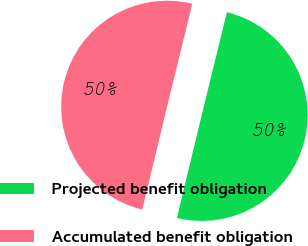Convert chart to OTSL. <chart><loc_0><loc_0><loc_500><loc_500><pie_chart><fcel>Projected benefit obligation<fcel>Accumulated benefit obligation<nl><fcel>49.94%<fcel>50.06%<nl></chart> 